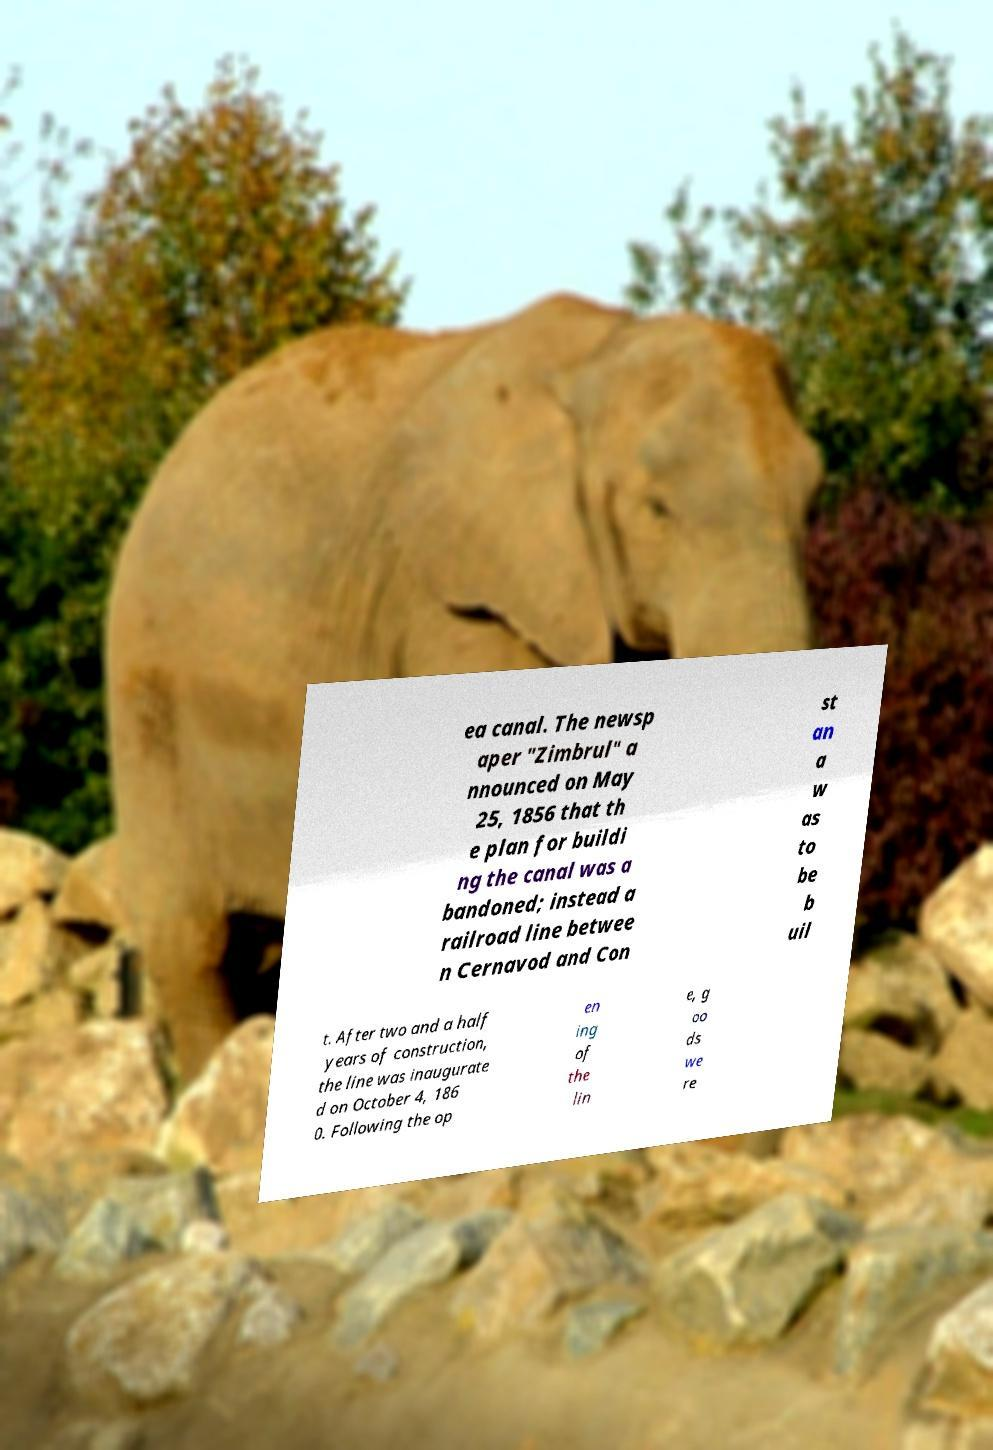Please identify and transcribe the text found in this image. ea canal. The newsp aper "Zimbrul" a nnounced on May 25, 1856 that th e plan for buildi ng the canal was a bandoned; instead a railroad line betwee n Cernavod and Con st an a w as to be b uil t. After two and a half years of construction, the line was inaugurate d on October 4, 186 0. Following the op en ing of the lin e, g oo ds we re 